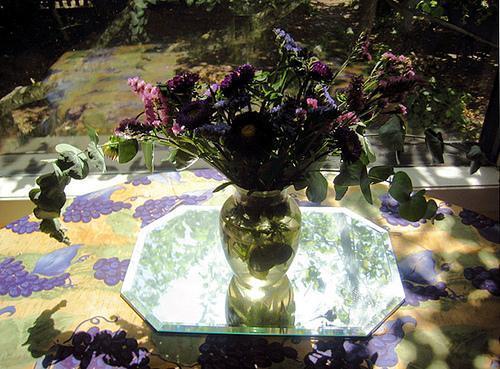How many vases are in the picture?
Give a very brief answer. 1. 